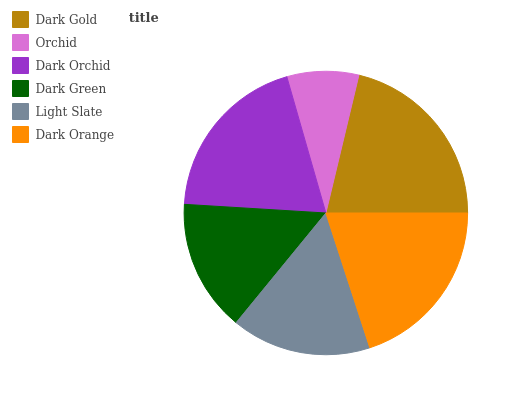Is Orchid the minimum?
Answer yes or no. Yes. Is Dark Gold the maximum?
Answer yes or no. Yes. Is Dark Orchid the minimum?
Answer yes or no. No. Is Dark Orchid the maximum?
Answer yes or no. No. Is Dark Orchid greater than Orchid?
Answer yes or no. Yes. Is Orchid less than Dark Orchid?
Answer yes or no. Yes. Is Orchid greater than Dark Orchid?
Answer yes or no. No. Is Dark Orchid less than Orchid?
Answer yes or no. No. Is Dark Orchid the high median?
Answer yes or no. Yes. Is Light Slate the low median?
Answer yes or no. Yes. Is Dark Green the high median?
Answer yes or no. No. Is Dark Orange the low median?
Answer yes or no. No. 